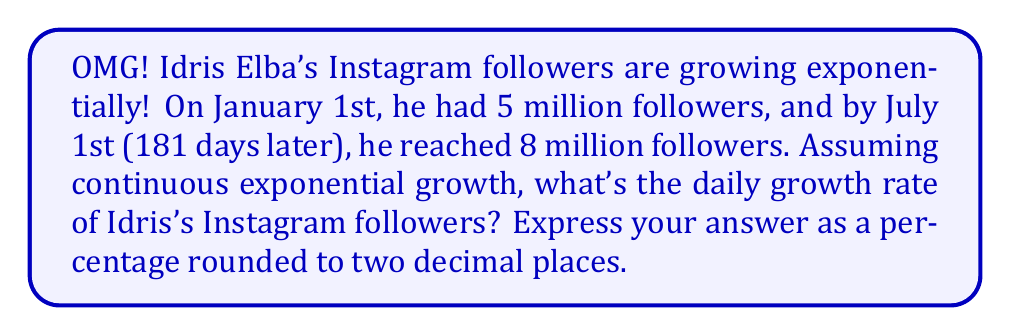Can you answer this question? Let's approach this step-by-step:

1) The exponential growth formula is:
   $$A = P \cdot e^{rt}$$
   Where:
   $A$ = Final amount
   $P$ = Initial amount
   $e$ = Euler's number (approximately 2.71828)
   $r$ = Growth rate (daily)
   $t$ = Time (in days)

2) We know:
   $P = 5$ million
   $A = 8$ million
   $t = 181$ days

3) Let's plug these into our formula:
   $$8 = 5 \cdot e^{181r}$$

4) Divide both sides by 5:
   $$\frac{8}{5} = e^{181r}$$

5) Take the natural log of both sides:
   $$\ln(\frac{8}{5}) = 181r$$

6) Solve for $r$:
   $$r = \frac{\ln(\frac{8}{5})}{181}$$

7) Calculate:
   $$r = \frac{\ln(1.6)}{181} \approx 0.002581$$

8) Convert to a percentage:
   $$0.002581 \cdot 100 \approx 0.2581\%$$

9) Round to two decimal places:
   $$0.26\%$$
Answer: 0.26% 